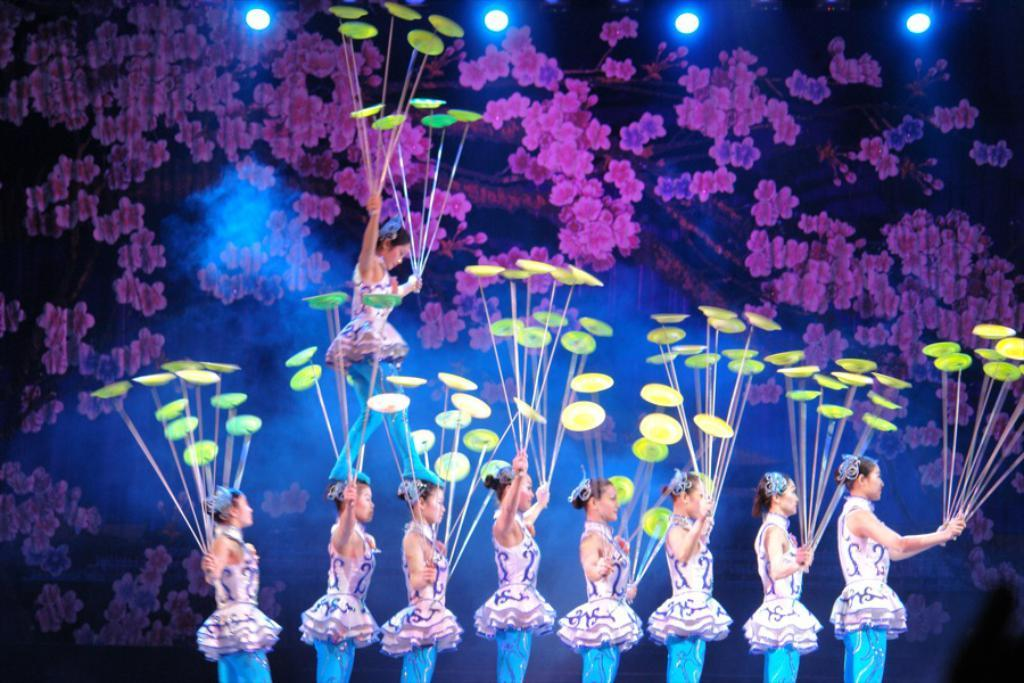What are the people in the image doing? The people in the image are performing plate spinning. What can be seen in the background of the image? There are focus lights and a curtain in the background of the image. What type of cloth is being used to test the strength of the plates in the image? There is no cloth or test being performed on the plates in the image; the people are simply spinning them. 